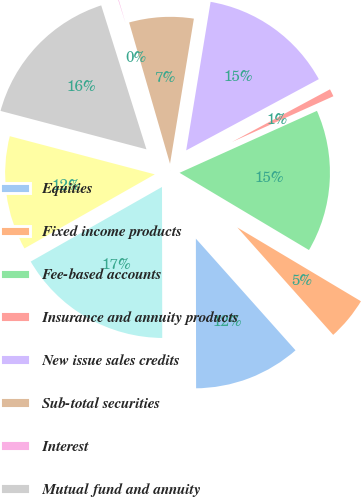Convert chart. <chart><loc_0><loc_0><loc_500><loc_500><pie_chart><fcel>Equities<fcel>Fixed income products<fcel>Fee-based accounts<fcel>Insurance and annuity products<fcel>New issue sales credits<fcel>Sub-total securities<fcel>Interest<fcel>Mutual fund and annuity<fcel>Client transaction fees<fcel>Correspondent clearing fees<nl><fcel>11.57%<fcel>4.84%<fcel>15.31%<fcel>1.1%<fcel>14.56%<fcel>7.08%<fcel>0.36%<fcel>16.06%<fcel>12.32%<fcel>16.8%<nl></chart> 